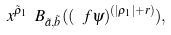<formula> <loc_0><loc_0><loc_500><loc_500>x ^ { \tilde { \rho } _ { 1 } } \ B _ { \tilde { a } , \tilde { b } } ( ( \ f \psi ) ^ { ( | \rho _ { 1 } | + r ) } ) ,</formula> 